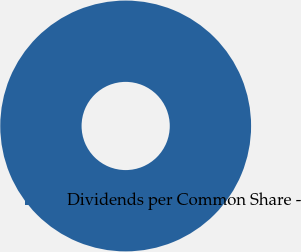Convert chart to OTSL. <chart><loc_0><loc_0><loc_500><loc_500><pie_chart><fcel>Dividends per Common Share -<nl><fcel>100.0%<nl></chart> 